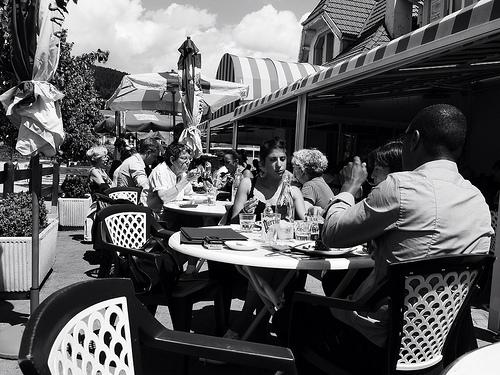What are people doing in this image? People are eating at a restaurant, having conversations, and enjoying food and drinks on the table. Discuss the setting of the image. The image is set outdoors at a busy restaurant with houses in the background and clouds in the sky. Mention something notable about the sky in the image. The sky has white, puffy clouds floating within it, in a grayish-black and white setting. Identify one furniture item that stands out in the image. A lattice back outdoor chair with a decorative touch can be noticed in the image. What makes this picture different in terms of color and composition? This picture is black and white, with a closed umbrella adding contrast to the scene. How would you describe the general mood of the scene? The scene is lively, with people having conversations, enjoying food, and participating in socializing at a busy outdoor restaurant. What clothing item is the woman wearing in the picture? The woman is wearing a black tank top on her upper body. What type of accessory does the man have in the image? The man has glasses on his head as a prominent accessory. What kind of food and drink items are on the table? There is a menu, a glass of water, plate, glasses, and silverware on the table. Find an unoccupied seat in the photo and describe it. There is an empty chair at the restaurant, it has a lattice back design and appears to be outdoors. 